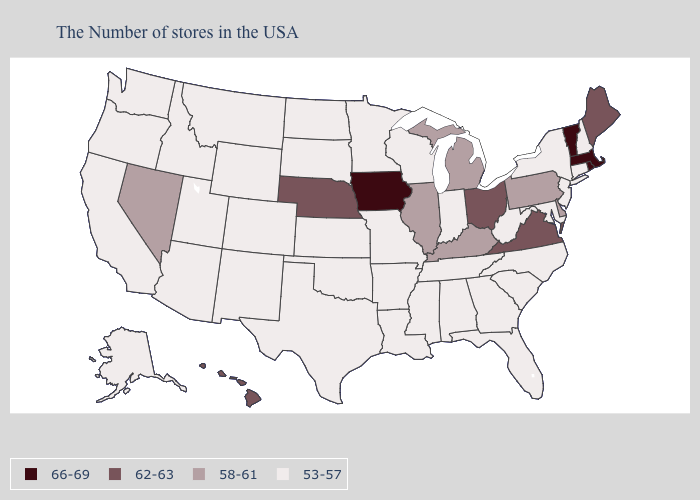Which states have the lowest value in the MidWest?
Concise answer only. Indiana, Wisconsin, Missouri, Minnesota, Kansas, South Dakota, North Dakota. What is the highest value in the West ?
Give a very brief answer. 62-63. Does Tennessee have the lowest value in the USA?
Quick response, please. Yes. Name the states that have a value in the range 66-69?
Write a very short answer. Massachusetts, Rhode Island, Vermont, Iowa. Does Kansas have a lower value than South Carolina?
Short answer required. No. What is the value of Montana?
Keep it brief. 53-57. Name the states that have a value in the range 62-63?
Answer briefly. Maine, Virginia, Ohio, Nebraska, Hawaii. What is the value of Nebraska?
Be succinct. 62-63. Does Washington have a lower value than Rhode Island?
Answer briefly. Yes. Which states have the highest value in the USA?
Give a very brief answer. Massachusetts, Rhode Island, Vermont, Iowa. Name the states that have a value in the range 66-69?
Keep it brief. Massachusetts, Rhode Island, Vermont, Iowa. What is the value of Indiana?
Write a very short answer. 53-57. What is the value of Mississippi?
Concise answer only. 53-57. Does the first symbol in the legend represent the smallest category?
Answer briefly. No. What is the value of North Dakota?
Quick response, please. 53-57. 